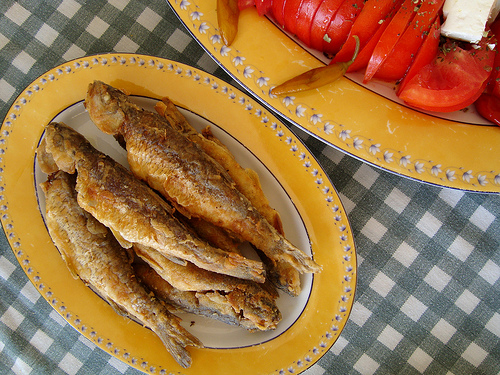<image>
Can you confirm if the food is next to the tomato piece? Yes. The food is positioned adjacent to the tomato piece, located nearby in the same general area. 